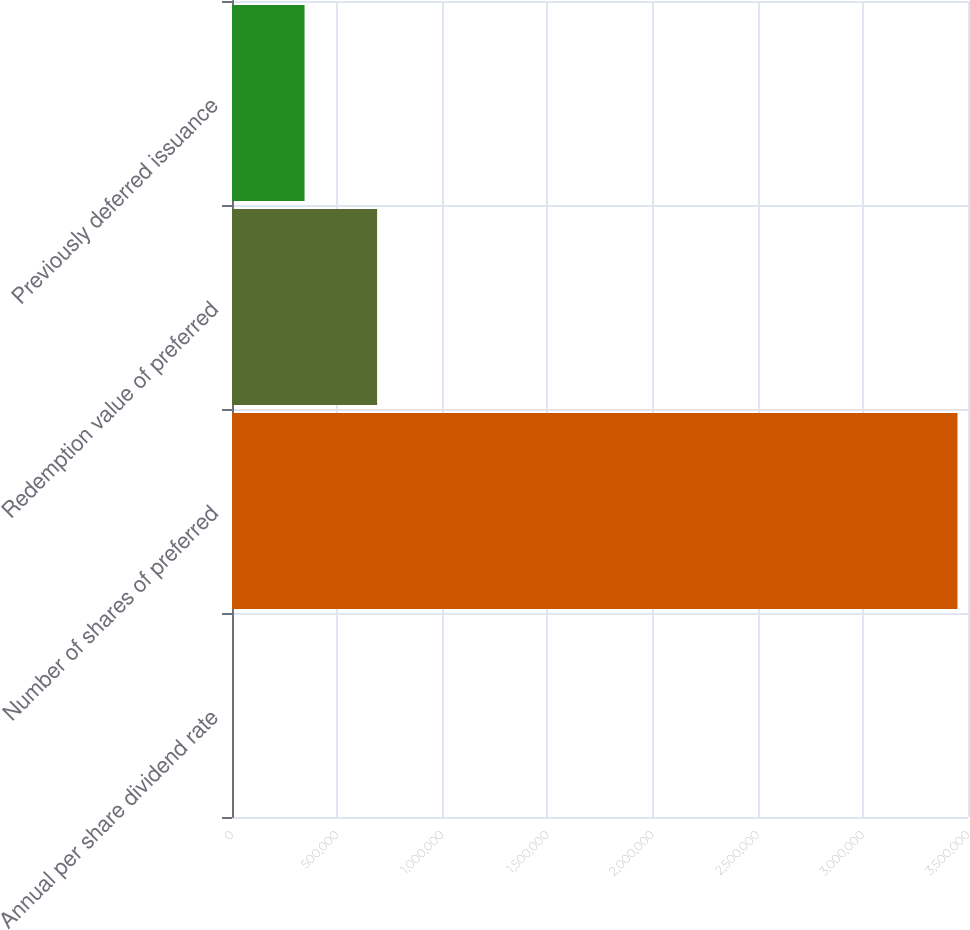Convert chart. <chart><loc_0><loc_0><loc_500><loc_500><bar_chart><fcel>Annual per share dividend rate<fcel>Number of shares of preferred<fcel>Redemption value of preferred<fcel>Previously deferred issuance<nl><fcel>7.88<fcel>3.45e+06<fcel>690006<fcel>345007<nl></chart> 